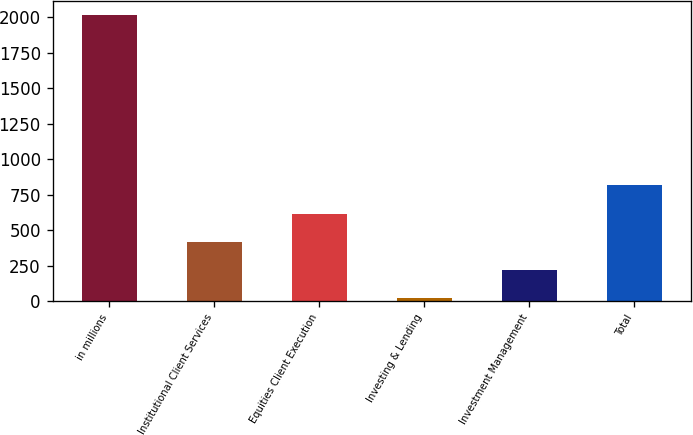Convert chart. <chart><loc_0><loc_0><loc_500><loc_500><bar_chart><fcel>in millions<fcel>Institutional Client Services<fcel>Equities Client Execution<fcel>Investing & Lending<fcel>Investment Management<fcel>Total<nl><fcel>2014<fcel>417.2<fcel>616.8<fcel>18<fcel>217.6<fcel>816.4<nl></chart> 